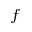<formula> <loc_0><loc_0><loc_500><loc_500>^ { f }</formula> 